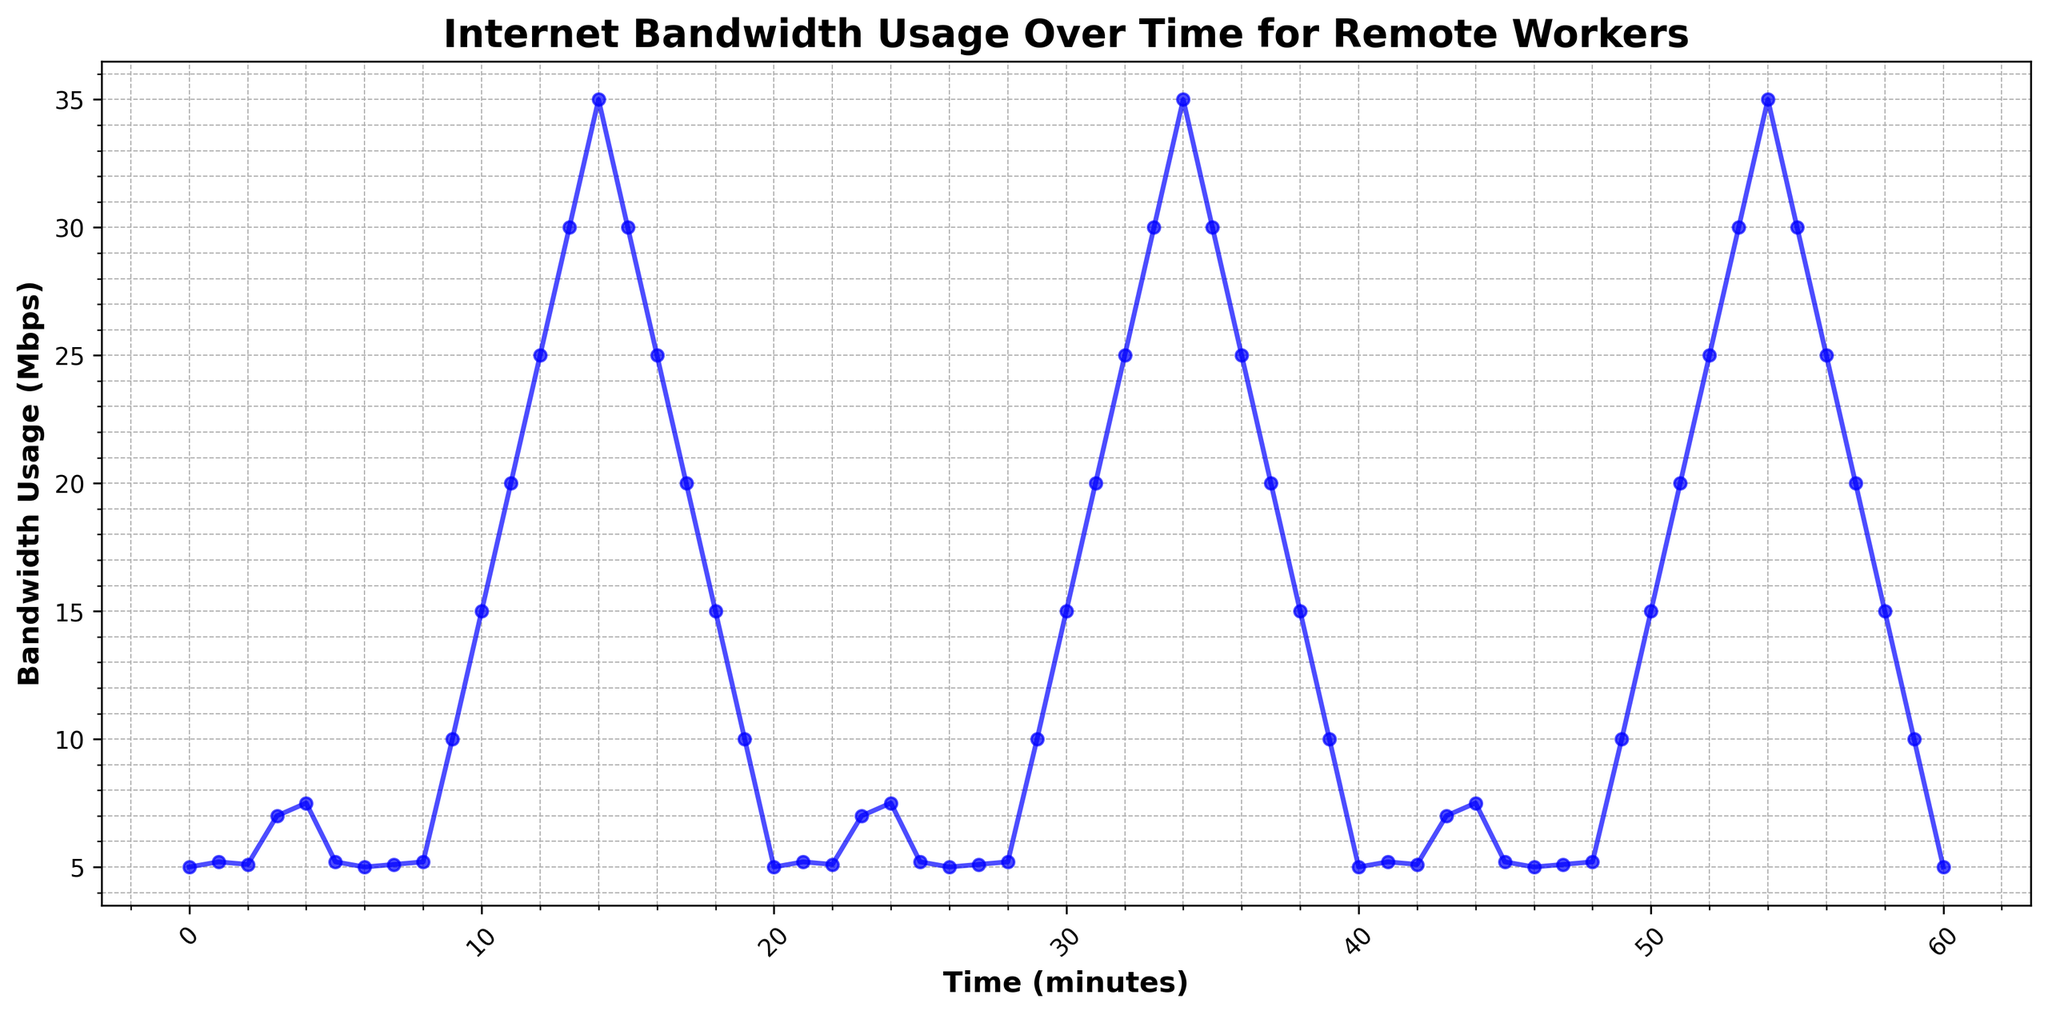What is the highest bandwidth usage recorded during the first 10 minutes? By observing the plot, the bandwidth usage peaks at multiple points. For the first 10 minutes, the highest value observed is at the 10th minute mark.
Answer: 15 Mbps What is the minimum bandwidth usage recorded during the entire 60 minutes? The plot shows the bandwidth usage varying over time. The minimum value observed consistently at multiple time points is 5 Mbps.
Answer: 5 Mbps At what time point does the bandwidth usage first reach 35 Mbps? From the graph, the rise to 35 Mbps can be detected by scanning the peaks. The first occurrence is around the 14th minute.
Answer: 14 minutes How many major peaks (identified as significantly higher than the surrounding points) are observed in the bandwidth usage within the entire 60 minutes? By counting the distinct high spikes that significantly stand out compared to surrounding points, it appears that there are three major peaks.
Answer: 3 peaks What is the average bandwidth usage from the 11th to the 20th minute? Find the data points in the given range and calculate their mean. The values are 20, 25, 30, 35, 30, 25, 20, 15, 10, and 5. Sum these values (20+25+30+35+30+25+20+15+10+5 = 215) and divide by the number of points (215 / 10).
Answer: 21.5 Mbps How does the bandwidth usage at the 20th minute compare to the usage at the 40th minute? The bandwidth usage at both 20 and 40 minutes is exactly 5 Mbps as evident from the plot.
Answer: Equal What trend is seen in the bandwidth usage from the 10th minute to the 17th minute? The plot shows a clear upward trend in bandwidth usage from the 10th minute (15 Mbps) peaking to 35 Mbps at the 14th minute, followed by a downward trend reaching 20 Mbps by the 17th minute.
Answer: Increase, then decrease What color is used to plot the bandwidth usage line? Observing the visual attributes of the plot, the line depicting the bandwidth usage over time is colored blue.
Answer: Blue 